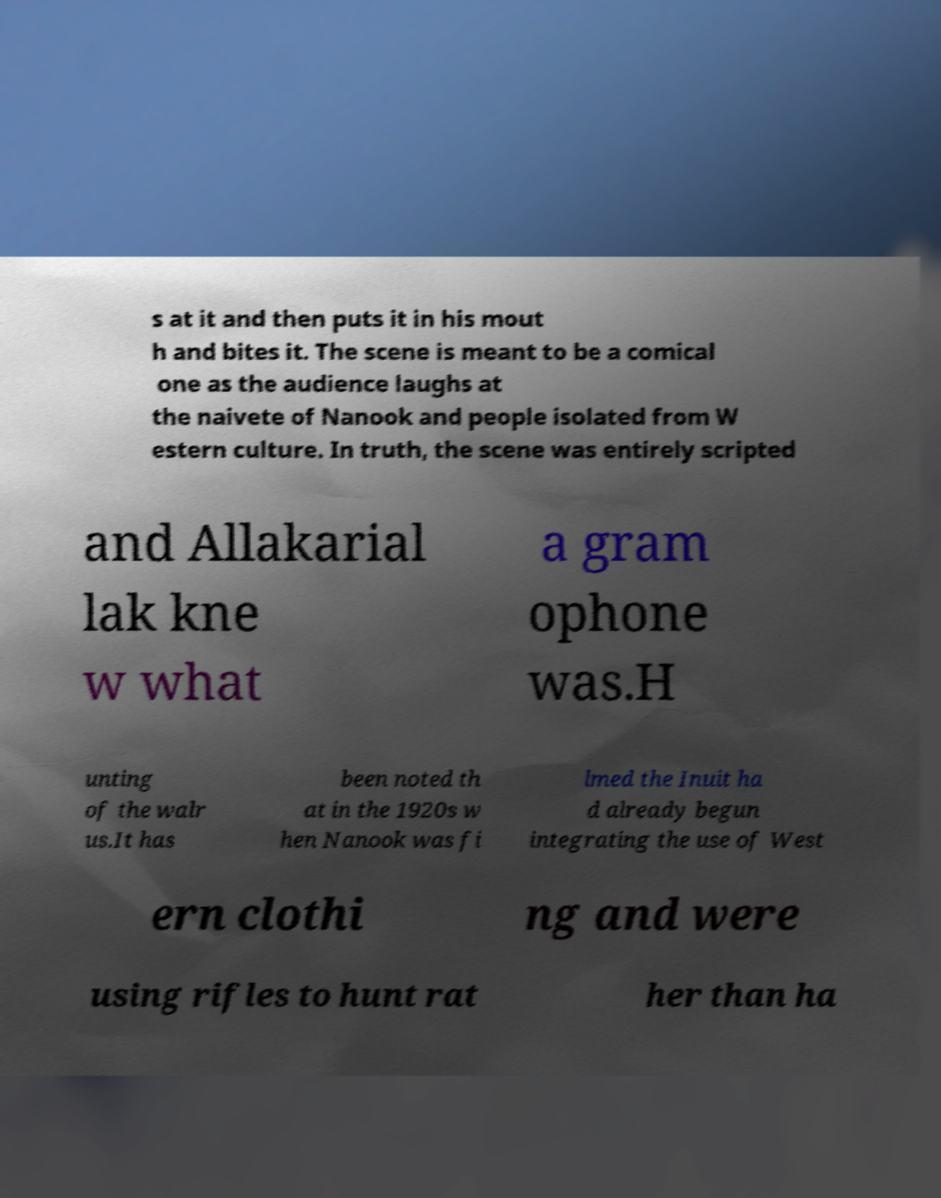Could you assist in decoding the text presented in this image and type it out clearly? s at it and then puts it in his mout h and bites it. The scene is meant to be a comical one as the audience laughs at the naivete of Nanook and people isolated from W estern culture. In truth, the scene was entirely scripted and Allakarial lak kne w what a gram ophone was.H unting of the walr us.It has been noted th at in the 1920s w hen Nanook was fi lmed the Inuit ha d already begun integrating the use of West ern clothi ng and were using rifles to hunt rat her than ha 